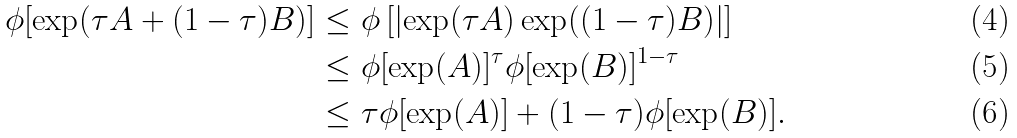<formula> <loc_0><loc_0><loc_500><loc_500>\phi [ \exp ( \tau A + ( 1 - \tau ) B ) ] \leq & \ \phi \left [ \left | \exp ( \tau A ) \exp ( ( 1 - \tau ) B ) \right | \right ] \\ \leq & \ \phi [ \exp ( A ) ] ^ { \tau } \phi [ \exp ( B ) ] ^ { 1 - \tau } \\ \leq & \ \tau \phi [ \exp ( A ) ] + ( 1 - \tau ) \phi [ \exp ( B ) ] .</formula> 